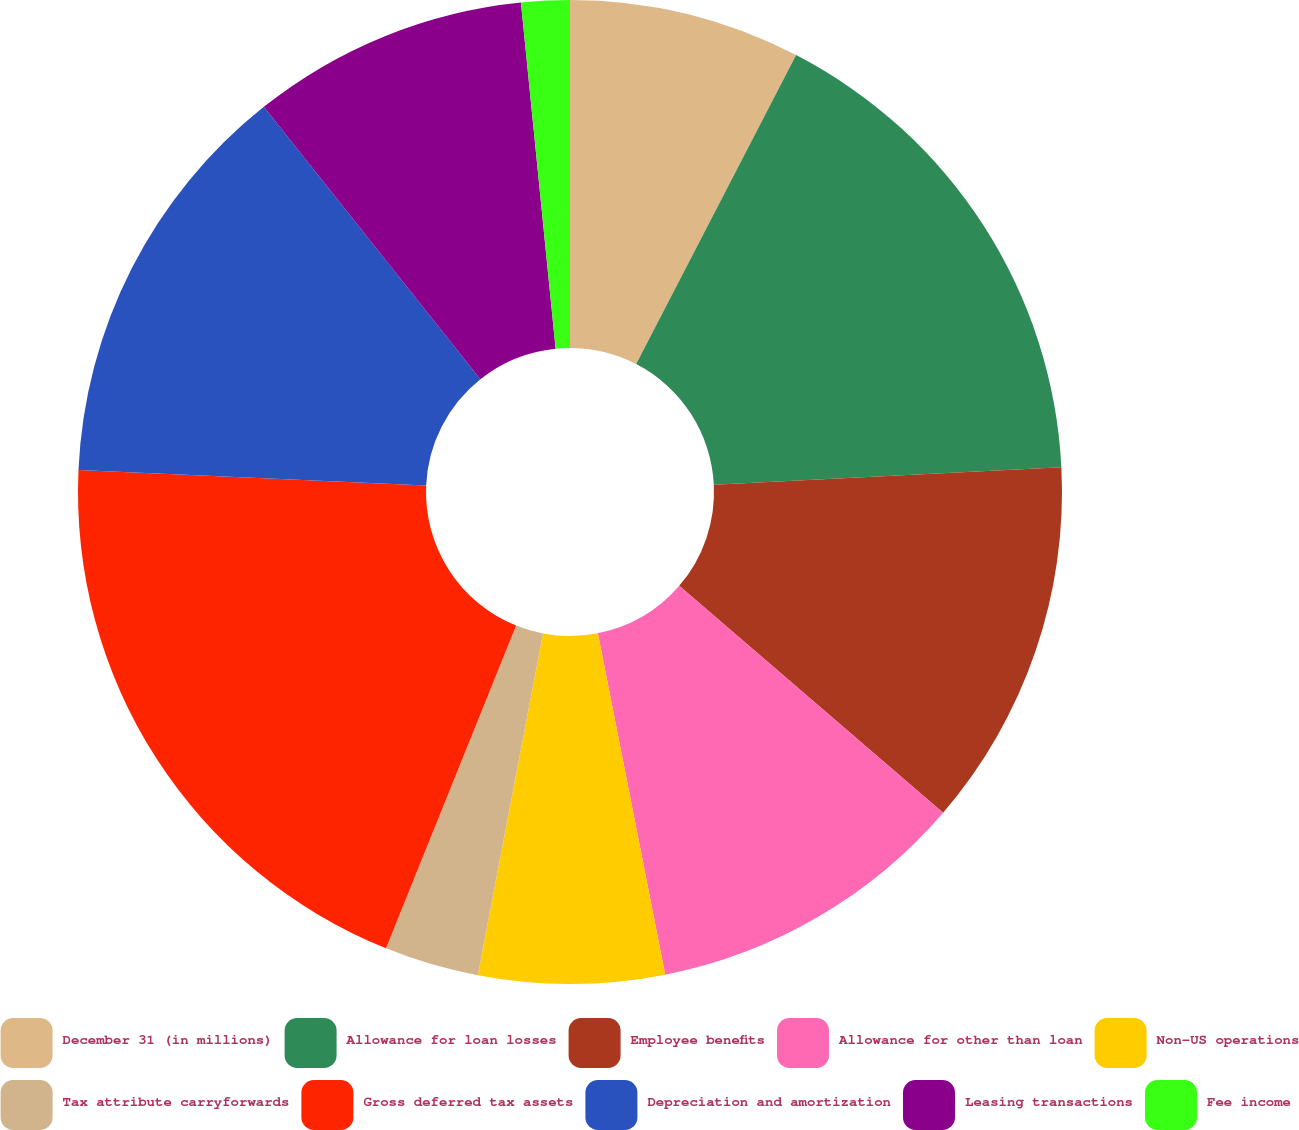Convert chart to OTSL. <chart><loc_0><loc_0><loc_500><loc_500><pie_chart><fcel>December 31 (in millions)<fcel>Allowance for loan losses<fcel>Employee benefits<fcel>Allowance for other than loan<fcel>Non-US operations<fcel>Tax attribute carryforwards<fcel>Gross deferred tax assets<fcel>Depreciation and amortization<fcel>Leasing transactions<fcel>Fee income<nl><fcel>7.6%<fcel>16.6%<fcel>12.1%<fcel>10.6%<fcel>6.1%<fcel>3.1%<fcel>19.61%<fcel>13.6%<fcel>9.1%<fcel>1.59%<nl></chart> 